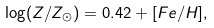<formula> <loc_0><loc_0><loc_500><loc_500>\log ( Z / Z _ { \odot } ) = 0 . 4 2 + [ F e / H ] ,</formula> 